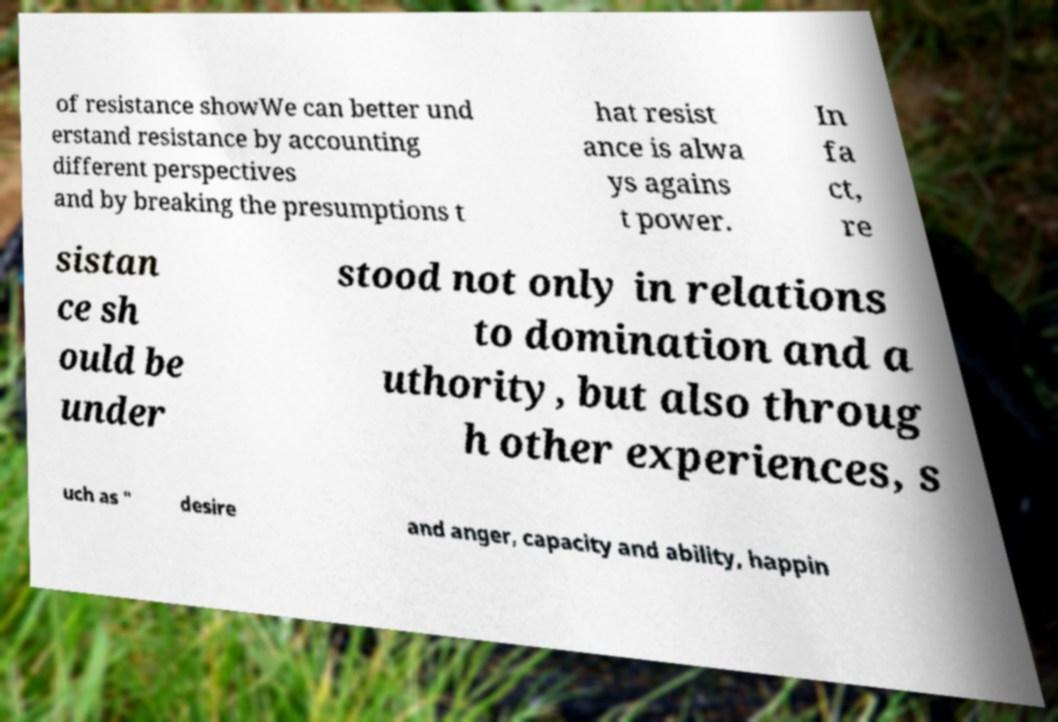Could you assist in decoding the text presented in this image and type it out clearly? of resistance showWe can better und erstand resistance by accounting different perspectives and by breaking the presumptions t hat resist ance is alwa ys agains t power. In fa ct, re sistan ce sh ould be under stood not only in relations to domination and a uthority, but also throug h other experiences, s uch as " desire and anger, capacity and ability, happin 